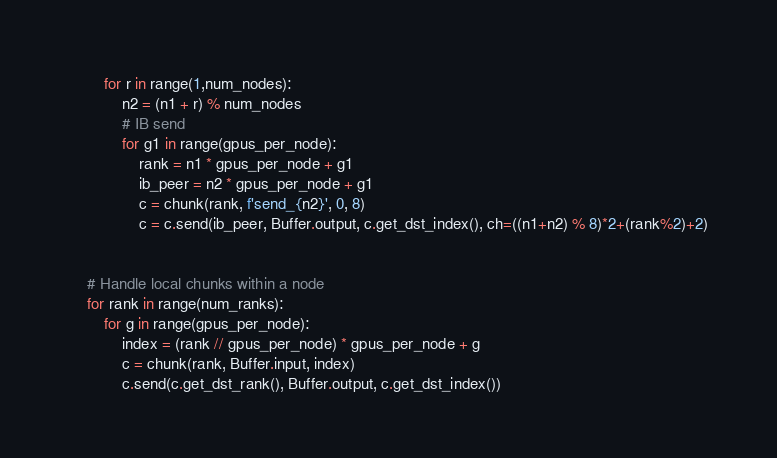<code> <loc_0><loc_0><loc_500><loc_500><_Python_>
        for r in range(1,num_nodes):
            n2 = (n1 + r) % num_nodes
            # IB send
            for g1 in range(gpus_per_node):
                rank = n1 * gpus_per_node + g1
                ib_peer = n2 * gpus_per_node + g1
                c = chunk(rank, f'send_{n2}', 0, 8)
                c = c.send(ib_peer, Buffer.output, c.get_dst_index(), ch=((n1+n2) % 8)*2+(rank%2)+2)

        
    # Handle local chunks within a node
    for rank in range(num_ranks):
        for g in range(gpus_per_node):
            index = (rank // gpus_per_node) * gpus_per_node + g
            c = chunk(rank, Buffer.input, index)
            c.send(c.get_dst_rank(), Buffer.output, c.get_dst_index())


</code> 